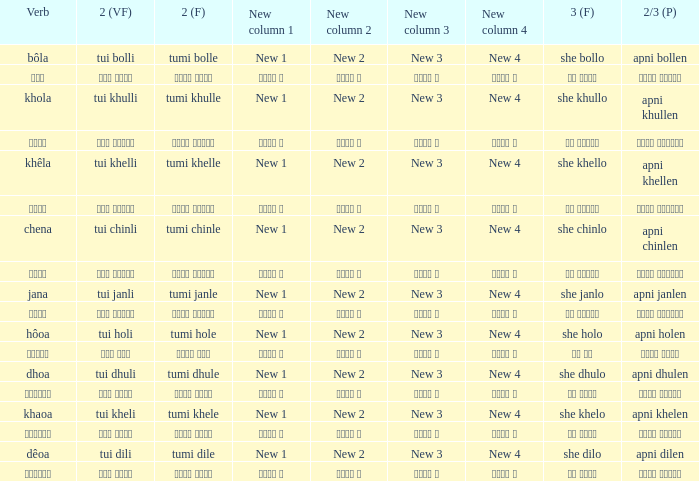Would you be able to parse every entry in this table? {'header': ['Verb', '2 (VF)', '2 (F)', 'New column 1', 'New column 2', 'New column 3', 'New column 4', '3 (F)', '2/3 (P)'], 'rows': [['bôla', 'tui bolli', 'tumi bolle', 'New 1', 'New 2', 'New 3', 'New 4', 'she bollo', 'apni bollen'], ['বলা', 'তুই বললি', 'তুমি বললে', 'নতুন ১', 'নতুন ২', 'নতুন ৩', 'নতুন ৪', 'সে বললো', 'আপনি বললেন'], ['khola', 'tui khulli', 'tumi khulle', 'New 1', 'New 2', 'New 3', 'New 4', 'she khullo', 'apni khullen'], ['খোলা', 'তুই খুললি', 'তুমি খুললে', 'নতুন ১', 'নতুন ২', 'নতুন ৩', 'নতুন ৪', 'সে খুললো', 'আপনি খুললেন'], ['khêla', 'tui khelli', 'tumi khelle', 'New 1', 'New 2', 'New 3', 'New 4', 'she khello', 'apni khellen'], ['খেলে', 'তুই খেললি', 'তুমি খেললে', 'নতুন ১', 'নতুন ২', 'নতুন ৩', 'নতুন ৪', 'সে খেললো', 'আপনি খেললেন'], ['chena', 'tui chinli', 'tumi chinle', 'New 1', 'New 2', 'New 3', 'New 4', 'she chinlo', 'apni chinlen'], ['চেনা', 'তুই চিনলি', 'তুমি চিনলে', 'নতুন ১', 'নতুন ২', 'নতুন ৩', 'নতুন ৪', 'সে চিনলো', 'আপনি চিনলেন'], ['jana', 'tui janli', 'tumi janle', 'New 1', 'New 2', 'New 3', 'New 4', 'she janlo', 'apni janlen'], ['জানা', 'তুই জানলি', 'তুমি জানলে', 'নতুন ১', 'নতুন ২', 'নতুন ৩', 'নতুন ৪', 'সে জানলে', 'আপনি জানলেন'], ['hôoa', 'tui holi', 'tumi hole', 'New 1', 'New 2', 'New 3', 'New 4', 'she holo', 'apni holen'], ['হওয়া', 'তুই হলি', 'তুমি হলে', 'নতুন ১', 'নতুন ২', 'নতুন ৩', 'নতুন ৪', 'সে হল', 'আপনি হলেন'], ['dhoa', 'tui dhuli', 'tumi dhule', 'New 1', 'New 2', 'New 3', 'New 4', 'she dhulo', 'apni dhulen'], ['ধোওয়া', 'তুই ধুলি', 'তুমি ধুলে', 'নতুন ১', 'নতুন ২', 'নতুন ৩', 'নতুন ৪', 'সে ধুলো', 'আপনি ধুলেন'], ['khaoa', 'tui kheli', 'tumi khele', 'New 1', 'New 2', 'New 3', 'New 4', 'she khelo', 'apni khelen'], ['খাওয়া', 'তুই খেলি', 'তুমি খেলে', 'নতুন ১', 'নতুন ২', 'নতুন ৩', 'নতুন ৪', 'সে খেলো', 'আপনি খেলেন'], ['dêoa', 'tui dili', 'tumi dile', 'New 1', 'New 2', 'New 3', 'New 4', 'she dilo', 'apni dilen'], ['দেওয়া', 'তুই দিলি', 'তুমি দিলে', 'নতুন ১', 'নতুন ২', 'নতুন ৩', 'নতুন ৪', 'সে দিলো', 'আপনি দিলেন']]} What verb is associated with "তুমি খেলে"? খাওয়া. 